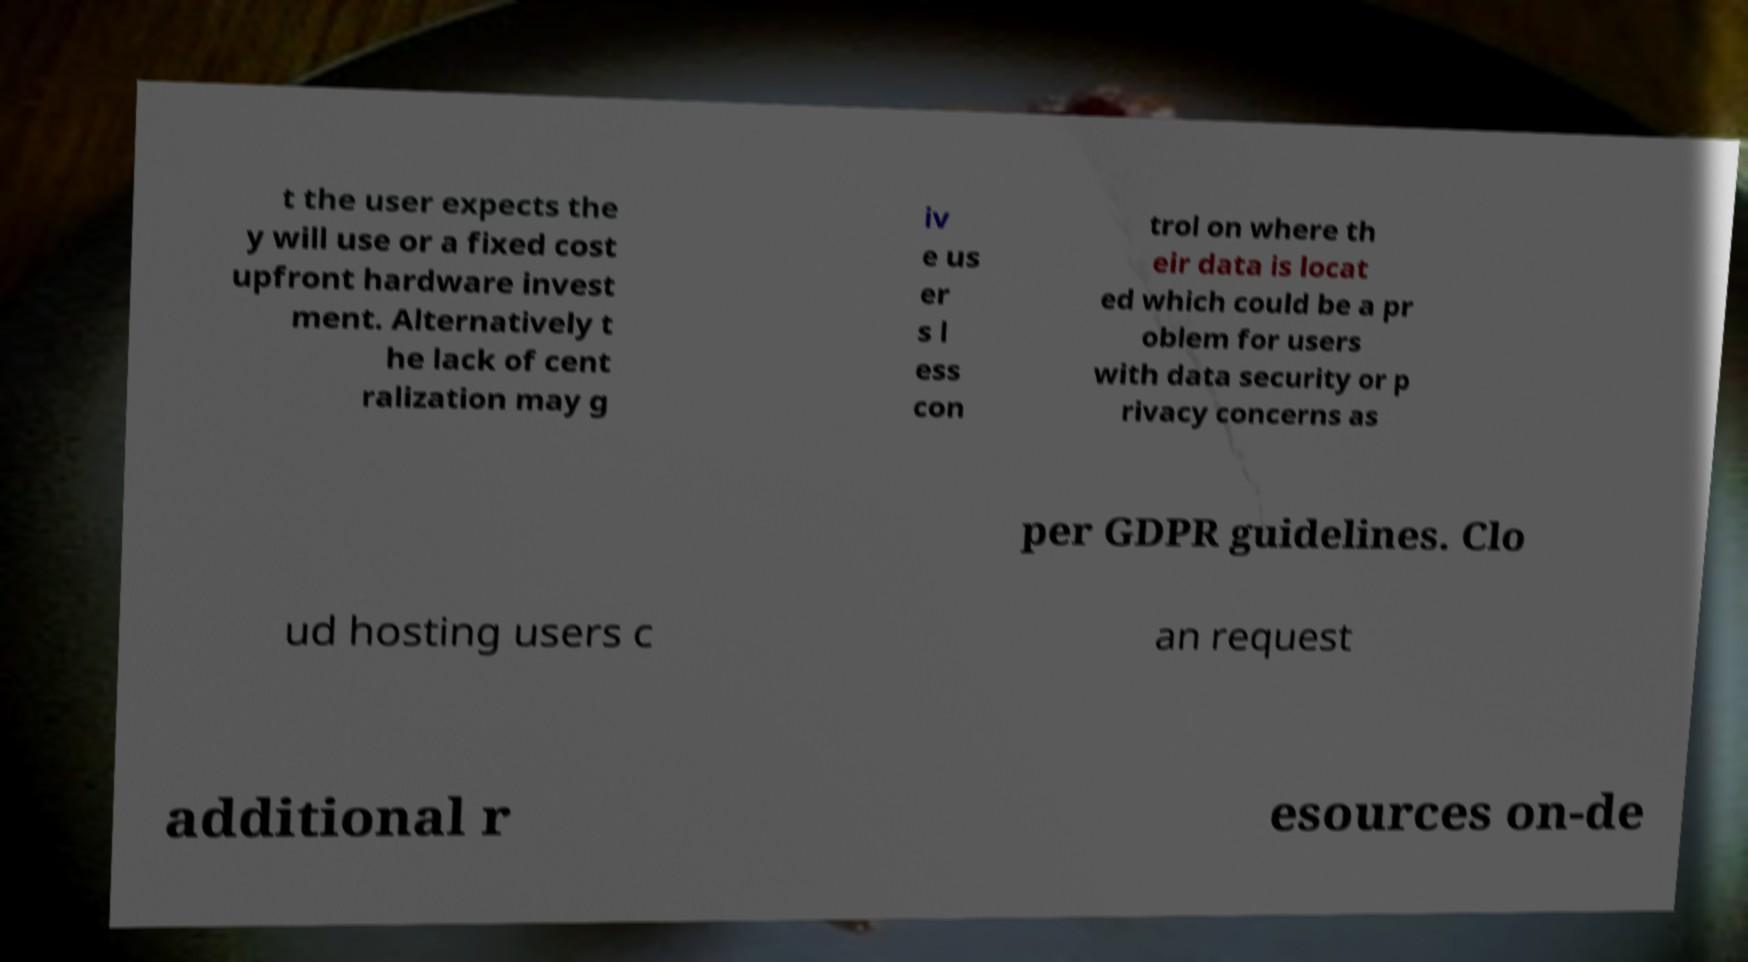There's text embedded in this image that I need extracted. Can you transcribe it verbatim? t the user expects the y will use or a fixed cost upfront hardware invest ment. Alternatively t he lack of cent ralization may g iv e us er s l ess con trol on where th eir data is locat ed which could be a pr oblem for users with data security or p rivacy concerns as per GDPR guidelines. Clo ud hosting users c an request additional r esources on-de 